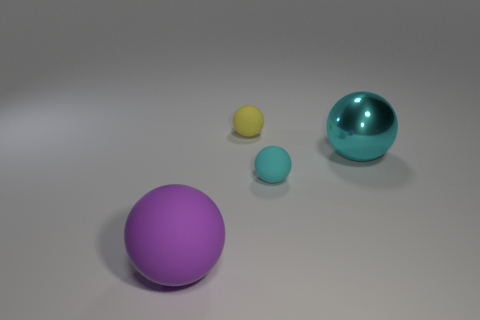Add 1 small balls. How many objects exist? 5 Subtract 0 red cubes. How many objects are left? 4 Subtract all tiny red rubber cubes. Subtract all yellow matte spheres. How many objects are left? 3 Add 3 tiny matte spheres. How many tiny matte spheres are left? 5 Add 2 big cyan shiny cylinders. How many big cyan shiny cylinders exist? 2 